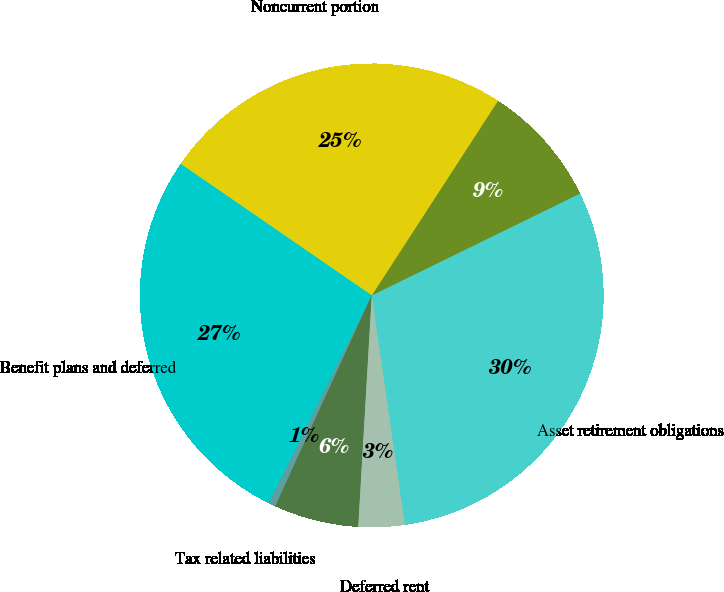Convert chart. <chart><loc_0><loc_0><loc_500><loc_500><pie_chart><fcel>Asset retirement obligations<fcel>Less Current portion in<fcel>Noncurrent portion<fcel>Benefit plans and deferred<fcel>Tax related liabilities<fcel>Environmental and related<fcel>Deferred rent<nl><fcel>29.96%<fcel>8.6%<fcel>24.56%<fcel>27.26%<fcel>0.5%<fcel>5.9%<fcel>3.2%<nl></chart> 